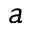Convert formula to latex. <formula><loc_0><loc_0><loc_500><loc_500>a</formula> 